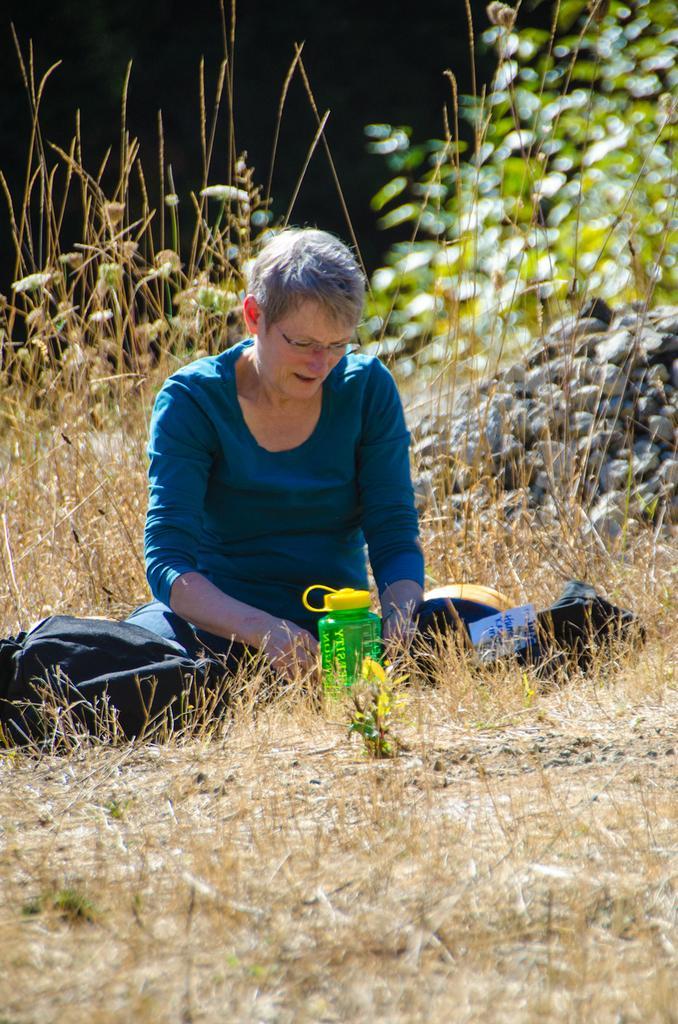Could you give a brief overview of what you see in this image? There is a woman sitting on the ground. There is a bag beside her. In front her there is a bottle. Behind her there is a rock. In the background there are some plants and grass in the ground. 